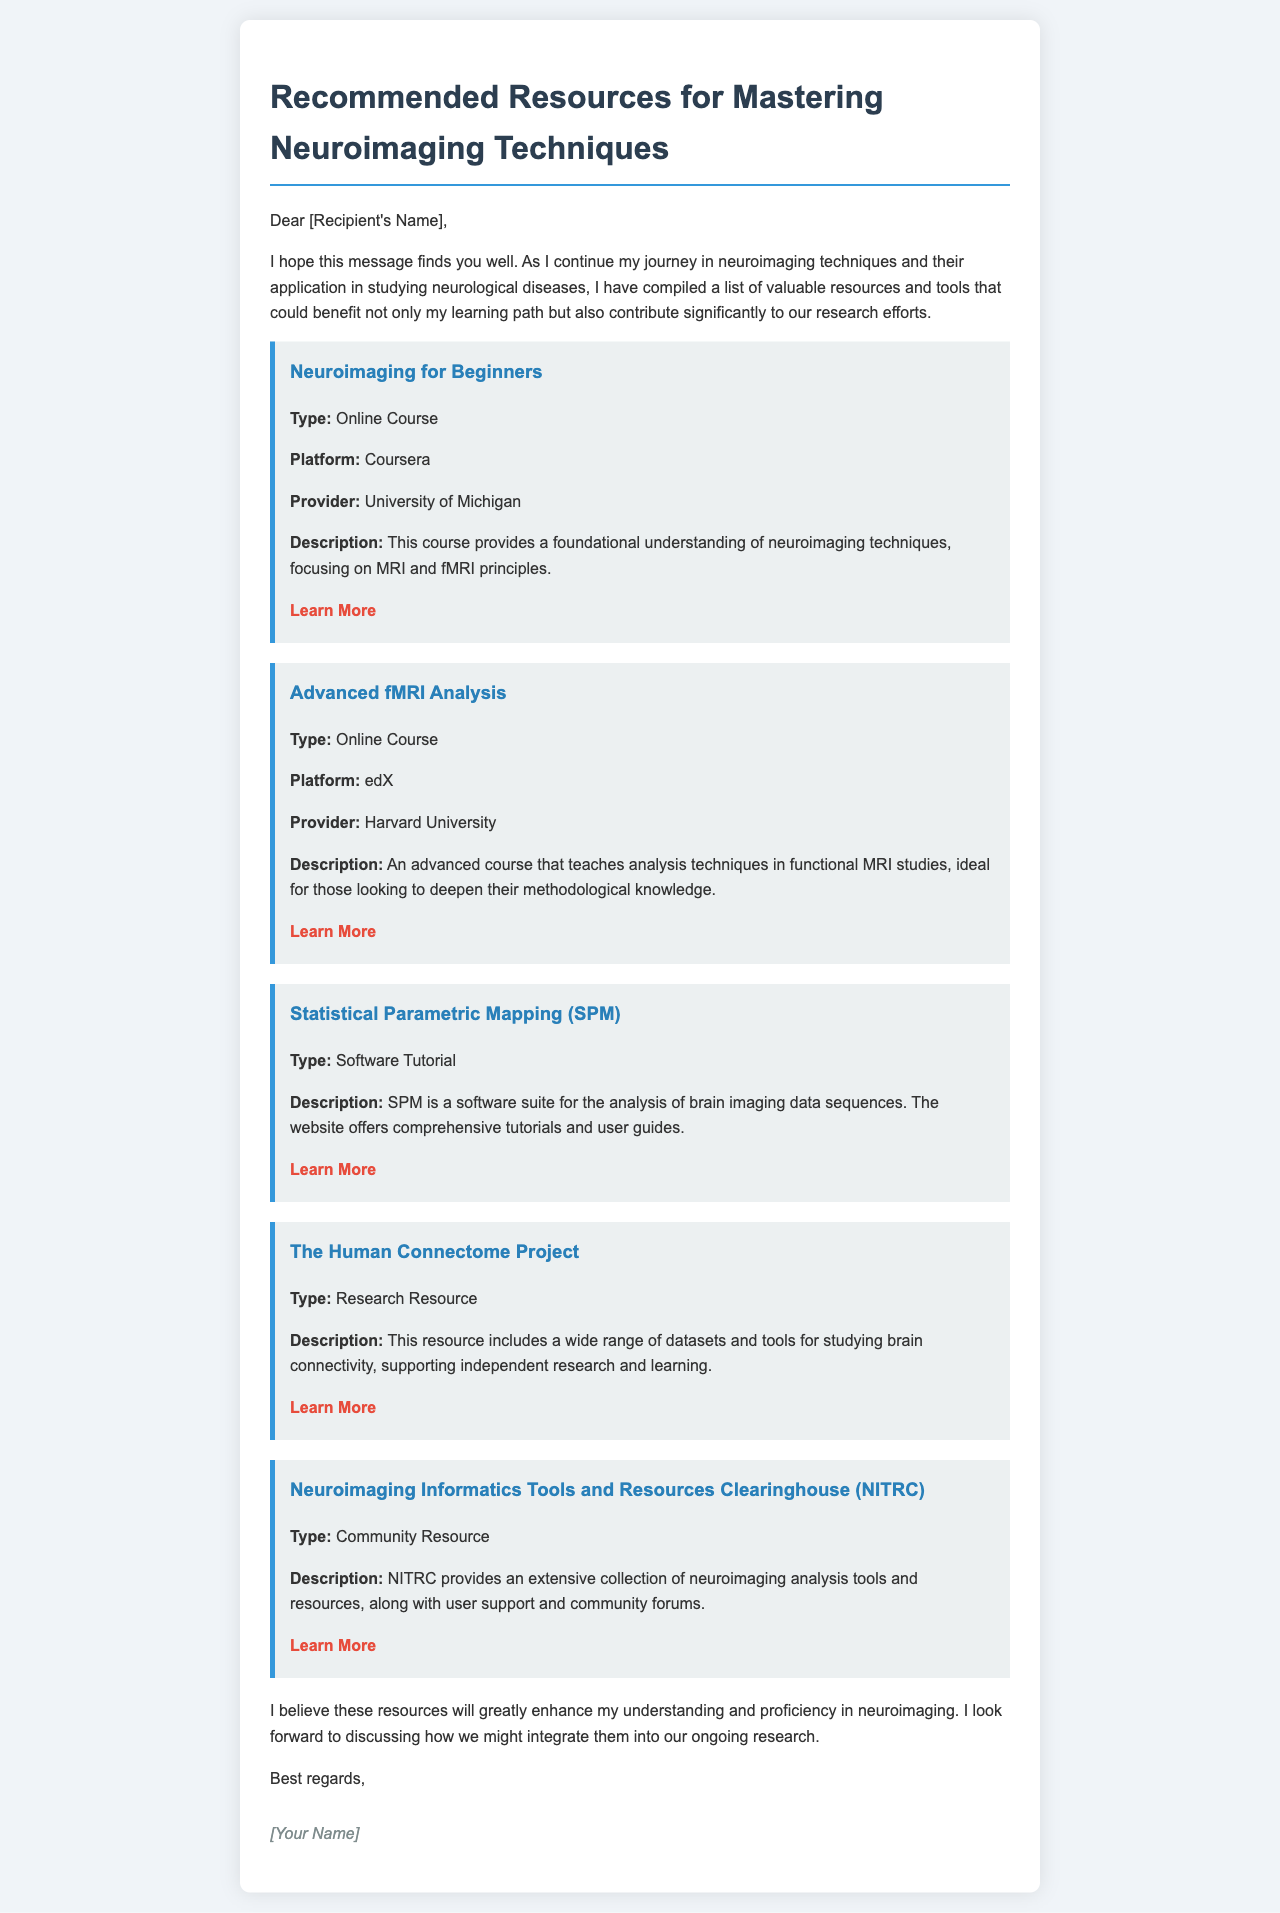What is the title of the email? The title is stated at the beginning of the document, which is "Recommended Resources for Mastering Neuroimaging Techniques."
Answer: Recommended Resources for Mastering Neuroimaging Techniques Who is the provider of the "Neuroimaging for Beginners" course? The provider is referenced within the resource description for the "Neuroimaging for Beginners" course.
Answer: University of Michigan What type of resource is the "Human Connectome Project"? The type is specified in the description of that resource in the document.
Answer: Research Resource How many online courses are listed in the document? There are two resources specifically mentioned as online courses.
Answer: 2 What is the focus of the "Advanced fMRI Analysis" course? The focus is detailed in the course's description, which emphasizes the analysis techniques in functional MRI studies.
Answer: Analysis techniques in functional MRI studies What does NITRC stand for? The abbreviation is included in the title of the resource "Neuroimaging Informatics Tools and Resources Clearinghouse (NITRC)."
Answer: Neuroimaging Informatics Tools and Resources Clearinghouse Which platform offers the "Advanced fMRI Analysis" course? The platform is mentioned in the resource details for that particular course.
Answer: edX What is a significant feature of SPM? The feature is outlined in the description, highlighting its purpose.
Answer: Software suite for the analysis of brain imaging data sequences 